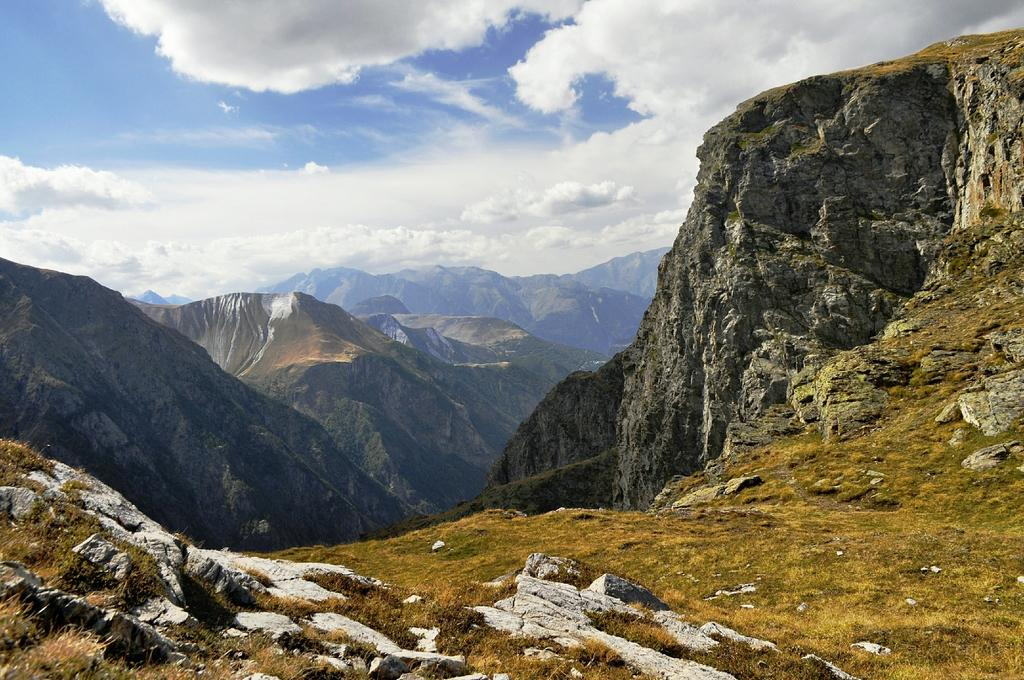What type of terrain is visible in the image? There is ground visible in the image. What natural features can be seen in the image? There are huge mountains in the image. What part of the natural environment is visible in the image? The sky is visible in the background of the image. Can you tell me how many rolls of fowl are visible in the image? There are no rolls of fowl present in the image; it features ground, mountains, and sky. 